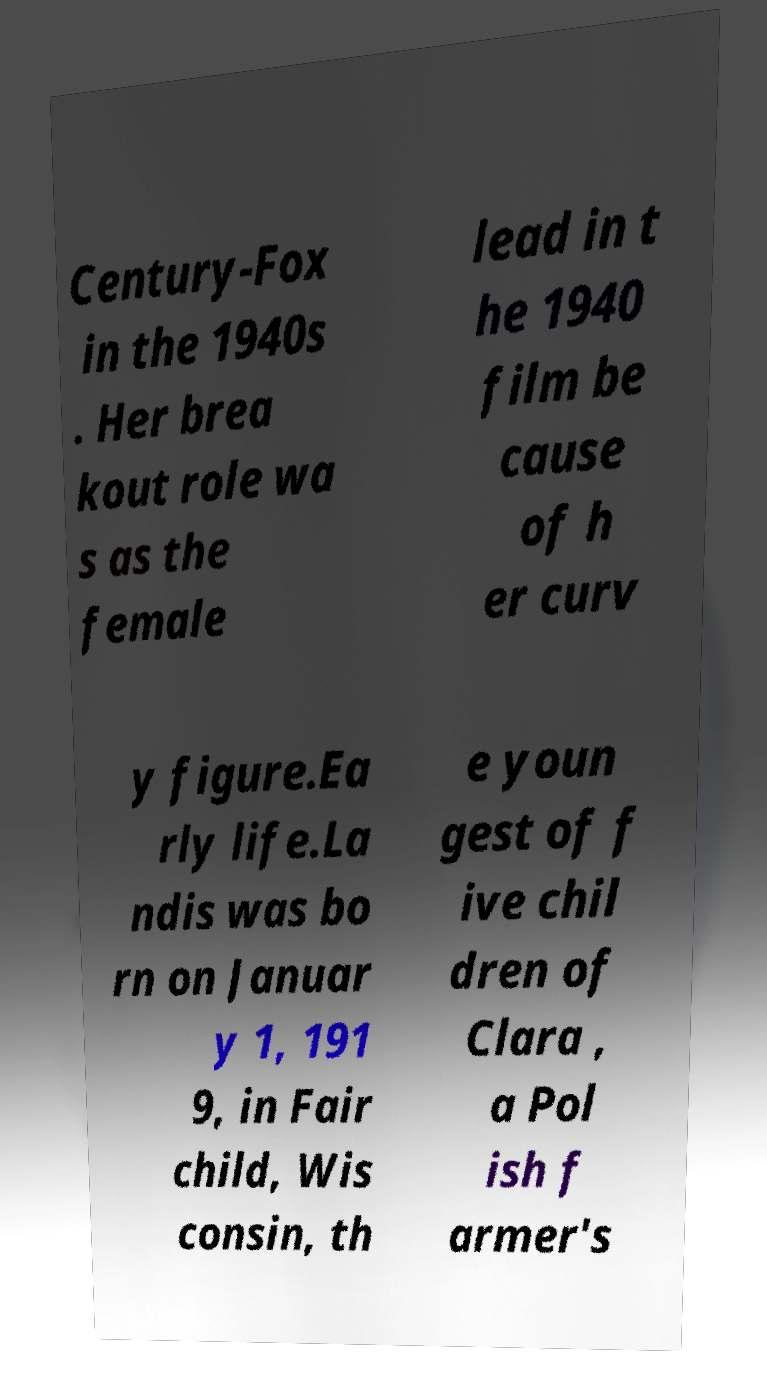I need the written content from this picture converted into text. Can you do that? Century-Fox in the 1940s . Her brea kout role wa s as the female lead in t he 1940 film be cause of h er curv y figure.Ea rly life.La ndis was bo rn on Januar y 1, 191 9, in Fair child, Wis consin, th e youn gest of f ive chil dren of Clara , a Pol ish f armer's 